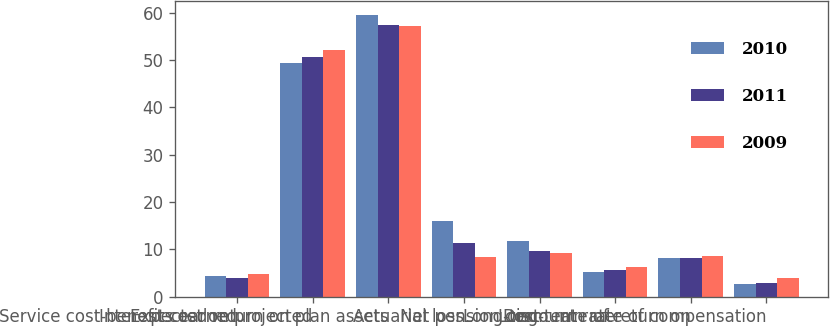Convert chart to OTSL. <chart><loc_0><loc_0><loc_500><loc_500><stacked_bar_chart><ecel><fcel>Service cost-benefits earned<fcel>Interest cost on projected<fcel>Expected return on plan assets<fcel>Actuarial loss<fcel>Net pension cost<fcel>Discount rate<fcel>Long-term rate of return on<fcel>Long-term rate of compensation<nl><fcel>2010<fcel>4.3<fcel>49.4<fcel>59.6<fcel>16.1<fcel>11.7<fcel>5.25<fcel>8.25<fcel>2.7<nl><fcel>2011<fcel>4<fcel>50.6<fcel>57.5<fcel>11.3<fcel>9.7<fcel>5.75<fcel>8.25<fcel>3<nl><fcel>2009<fcel>4.8<fcel>52.1<fcel>57.2<fcel>8.3<fcel>9.3<fcel>6.25<fcel>8.5<fcel>4<nl></chart> 